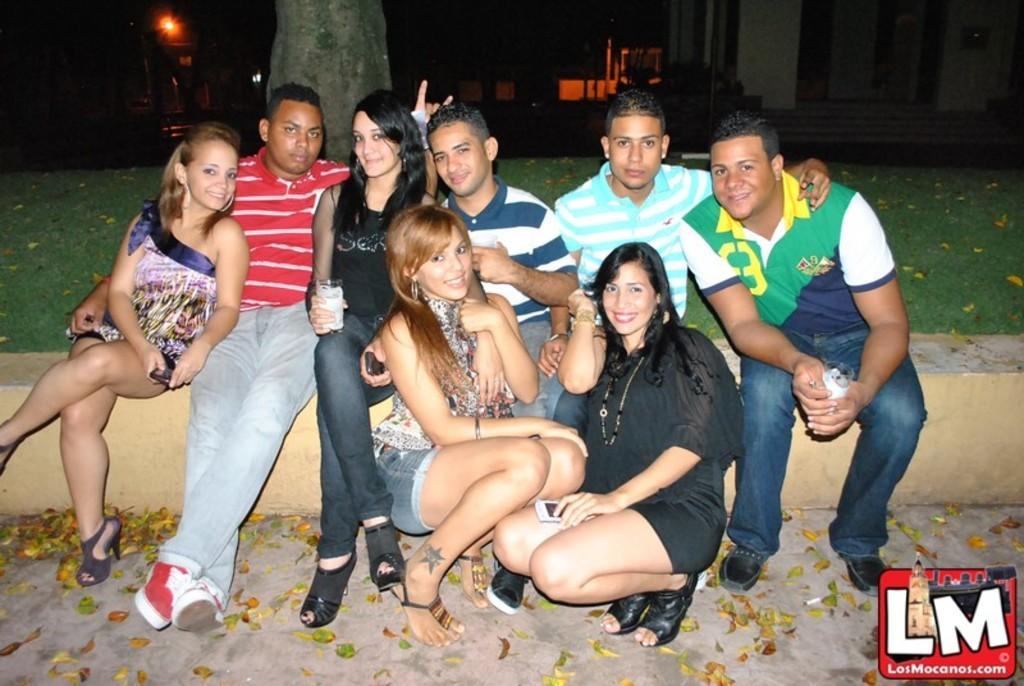What are the people in the image doing? The people in the image are sitting. What can be found at the right bottom of the image? There is a logo at the right bottom of the image. What type of natural environment is visible in the image? There is grass and a tree visible in the image. What can be seen in the background of the image? There is a light visible in the background of the image. What type of linen is being used by the people in the image? There is no mention of linen in the image, and it is not possible to determine the type of fabric the people are sitting on. 